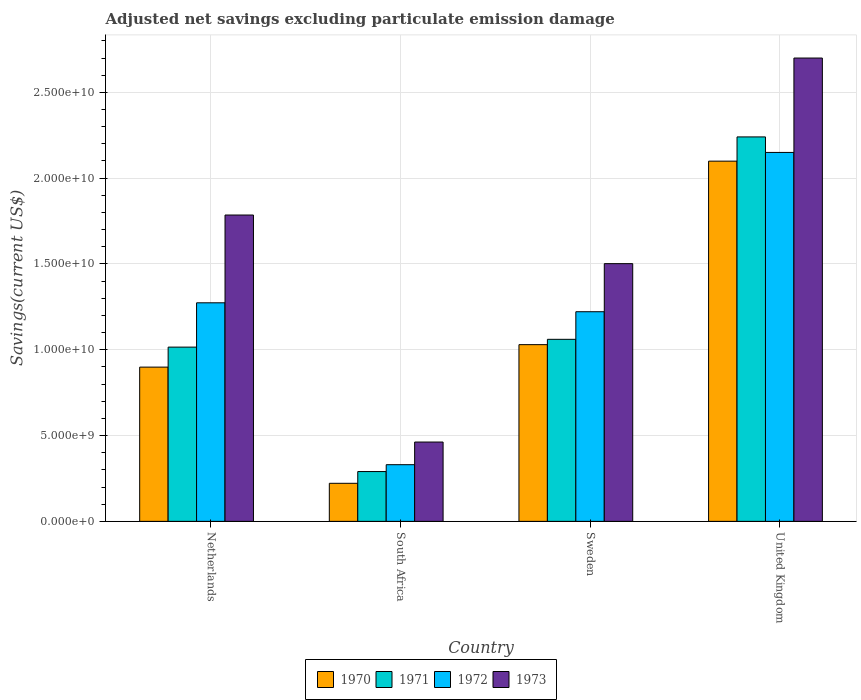Are the number of bars on each tick of the X-axis equal?
Provide a short and direct response. Yes. How many bars are there on the 2nd tick from the left?
Offer a very short reply. 4. What is the label of the 3rd group of bars from the left?
Your answer should be very brief. Sweden. In how many cases, is the number of bars for a given country not equal to the number of legend labels?
Your answer should be very brief. 0. What is the adjusted net savings in 1973 in Sweden?
Your answer should be compact. 1.50e+1. Across all countries, what is the maximum adjusted net savings in 1973?
Your answer should be very brief. 2.70e+1. Across all countries, what is the minimum adjusted net savings in 1970?
Give a very brief answer. 2.22e+09. In which country was the adjusted net savings in 1972 maximum?
Your answer should be compact. United Kingdom. In which country was the adjusted net savings in 1970 minimum?
Offer a terse response. South Africa. What is the total adjusted net savings in 1973 in the graph?
Offer a terse response. 6.45e+1. What is the difference between the adjusted net savings in 1973 in Sweden and that in United Kingdom?
Your answer should be compact. -1.20e+1. What is the difference between the adjusted net savings in 1970 in Netherlands and the adjusted net savings in 1971 in United Kingdom?
Your answer should be very brief. -1.34e+1. What is the average adjusted net savings in 1971 per country?
Your answer should be compact. 1.15e+1. What is the difference between the adjusted net savings of/in 1970 and adjusted net savings of/in 1973 in Netherlands?
Offer a very short reply. -8.86e+09. What is the ratio of the adjusted net savings in 1972 in Netherlands to that in South Africa?
Provide a succinct answer. 3.86. Is the adjusted net savings in 1973 in Sweden less than that in United Kingdom?
Provide a succinct answer. Yes. What is the difference between the highest and the second highest adjusted net savings in 1970?
Your answer should be compact. -1.07e+1. What is the difference between the highest and the lowest adjusted net savings in 1970?
Keep it short and to the point. 1.88e+1. In how many countries, is the adjusted net savings in 1973 greater than the average adjusted net savings in 1973 taken over all countries?
Give a very brief answer. 2. What does the 1st bar from the left in Netherlands represents?
Offer a terse response. 1970. How many bars are there?
Offer a very short reply. 16. Are all the bars in the graph horizontal?
Keep it short and to the point. No. What is the title of the graph?
Offer a terse response. Adjusted net savings excluding particulate emission damage. What is the label or title of the X-axis?
Provide a succinct answer. Country. What is the label or title of the Y-axis?
Your response must be concise. Savings(current US$). What is the Savings(current US$) of 1970 in Netherlands?
Offer a terse response. 8.99e+09. What is the Savings(current US$) in 1971 in Netherlands?
Ensure brevity in your answer.  1.02e+1. What is the Savings(current US$) in 1972 in Netherlands?
Keep it short and to the point. 1.27e+1. What is the Savings(current US$) of 1973 in Netherlands?
Your answer should be compact. 1.79e+1. What is the Savings(current US$) in 1970 in South Africa?
Keep it short and to the point. 2.22e+09. What is the Savings(current US$) in 1971 in South Africa?
Provide a succinct answer. 2.90e+09. What is the Savings(current US$) of 1972 in South Africa?
Your response must be concise. 3.30e+09. What is the Savings(current US$) of 1973 in South Africa?
Your response must be concise. 4.62e+09. What is the Savings(current US$) of 1970 in Sweden?
Give a very brief answer. 1.03e+1. What is the Savings(current US$) of 1971 in Sweden?
Your answer should be compact. 1.06e+1. What is the Savings(current US$) of 1972 in Sweden?
Offer a terse response. 1.22e+1. What is the Savings(current US$) of 1973 in Sweden?
Provide a succinct answer. 1.50e+1. What is the Savings(current US$) of 1970 in United Kingdom?
Ensure brevity in your answer.  2.10e+1. What is the Savings(current US$) of 1971 in United Kingdom?
Ensure brevity in your answer.  2.24e+1. What is the Savings(current US$) in 1972 in United Kingdom?
Ensure brevity in your answer.  2.15e+1. What is the Savings(current US$) of 1973 in United Kingdom?
Provide a succinct answer. 2.70e+1. Across all countries, what is the maximum Savings(current US$) in 1970?
Keep it short and to the point. 2.10e+1. Across all countries, what is the maximum Savings(current US$) in 1971?
Your answer should be compact. 2.24e+1. Across all countries, what is the maximum Savings(current US$) of 1972?
Keep it short and to the point. 2.15e+1. Across all countries, what is the maximum Savings(current US$) of 1973?
Provide a succinct answer. 2.70e+1. Across all countries, what is the minimum Savings(current US$) of 1970?
Your answer should be very brief. 2.22e+09. Across all countries, what is the minimum Savings(current US$) in 1971?
Your response must be concise. 2.90e+09. Across all countries, what is the minimum Savings(current US$) of 1972?
Keep it short and to the point. 3.30e+09. Across all countries, what is the minimum Savings(current US$) in 1973?
Offer a terse response. 4.62e+09. What is the total Savings(current US$) in 1970 in the graph?
Provide a succinct answer. 4.25e+1. What is the total Savings(current US$) in 1971 in the graph?
Your answer should be compact. 4.61e+1. What is the total Savings(current US$) in 1972 in the graph?
Ensure brevity in your answer.  4.98e+1. What is the total Savings(current US$) in 1973 in the graph?
Ensure brevity in your answer.  6.45e+1. What is the difference between the Savings(current US$) of 1970 in Netherlands and that in South Africa?
Offer a terse response. 6.77e+09. What is the difference between the Savings(current US$) in 1971 in Netherlands and that in South Africa?
Make the answer very short. 7.25e+09. What is the difference between the Savings(current US$) in 1972 in Netherlands and that in South Africa?
Your answer should be compact. 9.43e+09. What is the difference between the Savings(current US$) of 1973 in Netherlands and that in South Africa?
Your answer should be compact. 1.32e+1. What is the difference between the Savings(current US$) of 1970 in Netherlands and that in Sweden?
Provide a succinct answer. -1.31e+09. What is the difference between the Savings(current US$) in 1971 in Netherlands and that in Sweden?
Provide a succinct answer. -4.54e+08. What is the difference between the Savings(current US$) of 1972 in Netherlands and that in Sweden?
Give a very brief answer. 5.20e+08. What is the difference between the Savings(current US$) in 1973 in Netherlands and that in Sweden?
Your answer should be very brief. 2.83e+09. What is the difference between the Savings(current US$) in 1970 in Netherlands and that in United Kingdom?
Offer a terse response. -1.20e+1. What is the difference between the Savings(current US$) in 1971 in Netherlands and that in United Kingdom?
Make the answer very short. -1.22e+1. What is the difference between the Savings(current US$) in 1972 in Netherlands and that in United Kingdom?
Your answer should be very brief. -8.76e+09. What is the difference between the Savings(current US$) in 1973 in Netherlands and that in United Kingdom?
Give a very brief answer. -9.15e+09. What is the difference between the Savings(current US$) in 1970 in South Africa and that in Sweden?
Your answer should be compact. -8.08e+09. What is the difference between the Savings(current US$) of 1971 in South Africa and that in Sweden?
Ensure brevity in your answer.  -7.70e+09. What is the difference between the Savings(current US$) of 1972 in South Africa and that in Sweden?
Provide a short and direct response. -8.91e+09. What is the difference between the Savings(current US$) in 1973 in South Africa and that in Sweden?
Your response must be concise. -1.04e+1. What is the difference between the Savings(current US$) of 1970 in South Africa and that in United Kingdom?
Your response must be concise. -1.88e+1. What is the difference between the Savings(current US$) in 1971 in South Africa and that in United Kingdom?
Give a very brief answer. -1.95e+1. What is the difference between the Savings(current US$) in 1972 in South Africa and that in United Kingdom?
Provide a succinct answer. -1.82e+1. What is the difference between the Savings(current US$) of 1973 in South Africa and that in United Kingdom?
Provide a succinct answer. -2.24e+1. What is the difference between the Savings(current US$) of 1970 in Sweden and that in United Kingdom?
Offer a very short reply. -1.07e+1. What is the difference between the Savings(current US$) in 1971 in Sweden and that in United Kingdom?
Offer a very short reply. -1.18e+1. What is the difference between the Savings(current US$) in 1972 in Sweden and that in United Kingdom?
Give a very brief answer. -9.28e+09. What is the difference between the Savings(current US$) of 1973 in Sweden and that in United Kingdom?
Keep it short and to the point. -1.20e+1. What is the difference between the Savings(current US$) of 1970 in Netherlands and the Savings(current US$) of 1971 in South Africa?
Ensure brevity in your answer.  6.09e+09. What is the difference between the Savings(current US$) of 1970 in Netherlands and the Savings(current US$) of 1972 in South Africa?
Ensure brevity in your answer.  5.69e+09. What is the difference between the Savings(current US$) in 1970 in Netherlands and the Savings(current US$) in 1973 in South Africa?
Offer a terse response. 4.37e+09. What is the difference between the Savings(current US$) in 1971 in Netherlands and the Savings(current US$) in 1972 in South Africa?
Give a very brief answer. 6.85e+09. What is the difference between the Savings(current US$) of 1971 in Netherlands and the Savings(current US$) of 1973 in South Africa?
Offer a terse response. 5.53e+09. What is the difference between the Savings(current US$) in 1972 in Netherlands and the Savings(current US$) in 1973 in South Africa?
Your answer should be very brief. 8.11e+09. What is the difference between the Savings(current US$) in 1970 in Netherlands and the Savings(current US$) in 1971 in Sweden?
Offer a terse response. -1.62e+09. What is the difference between the Savings(current US$) of 1970 in Netherlands and the Savings(current US$) of 1972 in Sweden?
Make the answer very short. -3.23e+09. What is the difference between the Savings(current US$) in 1970 in Netherlands and the Savings(current US$) in 1973 in Sweden?
Offer a very short reply. -6.03e+09. What is the difference between the Savings(current US$) in 1971 in Netherlands and the Savings(current US$) in 1972 in Sweden?
Offer a very short reply. -2.06e+09. What is the difference between the Savings(current US$) in 1971 in Netherlands and the Savings(current US$) in 1973 in Sweden?
Keep it short and to the point. -4.86e+09. What is the difference between the Savings(current US$) of 1972 in Netherlands and the Savings(current US$) of 1973 in Sweden?
Offer a very short reply. -2.28e+09. What is the difference between the Savings(current US$) in 1970 in Netherlands and the Savings(current US$) in 1971 in United Kingdom?
Your answer should be compact. -1.34e+1. What is the difference between the Savings(current US$) of 1970 in Netherlands and the Savings(current US$) of 1972 in United Kingdom?
Your response must be concise. -1.25e+1. What is the difference between the Savings(current US$) in 1970 in Netherlands and the Savings(current US$) in 1973 in United Kingdom?
Your answer should be compact. -1.80e+1. What is the difference between the Savings(current US$) in 1971 in Netherlands and the Savings(current US$) in 1972 in United Kingdom?
Make the answer very short. -1.13e+1. What is the difference between the Savings(current US$) in 1971 in Netherlands and the Savings(current US$) in 1973 in United Kingdom?
Provide a succinct answer. -1.68e+1. What is the difference between the Savings(current US$) in 1972 in Netherlands and the Savings(current US$) in 1973 in United Kingdom?
Make the answer very short. -1.43e+1. What is the difference between the Savings(current US$) in 1970 in South Africa and the Savings(current US$) in 1971 in Sweden?
Provide a succinct answer. -8.39e+09. What is the difference between the Savings(current US$) in 1970 in South Africa and the Savings(current US$) in 1972 in Sweden?
Your answer should be very brief. -1.00e+1. What is the difference between the Savings(current US$) in 1970 in South Africa and the Savings(current US$) in 1973 in Sweden?
Offer a terse response. -1.28e+1. What is the difference between the Savings(current US$) of 1971 in South Africa and the Savings(current US$) of 1972 in Sweden?
Give a very brief answer. -9.31e+09. What is the difference between the Savings(current US$) of 1971 in South Africa and the Savings(current US$) of 1973 in Sweden?
Your response must be concise. -1.21e+1. What is the difference between the Savings(current US$) in 1972 in South Africa and the Savings(current US$) in 1973 in Sweden?
Make the answer very short. -1.17e+1. What is the difference between the Savings(current US$) of 1970 in South Africa and the Savings(current US$) of 1971 in United Kingdom?
Offer a terse response. -2.02e+1. What is the difference between the Savings(current US$) in 1970 in South Africa and the Savings(current US$) in 1972 in United Kingdom?
Give a very brief answer. -1.93e+1. What is the difference between the Savings(current US$) of 1970 in South Africa and the Savings(current US$) of 1973 in United Kingdom?
Provide a succinct answer. -2.48e+1. What is the difference between the Savings(current US$) of 1971 in South Africa and the Savings(current US$) of 1972 in United Kingdom?
Your answer should be compact. -1.86e+1. What is the difference between the Savings(current US$) in 1971 in South Africa and the Savings(current US$) in 1973 in United Kingdom?
Keep it short and to the point. -2.41e+1. What is the difference between the Savings(current US$) of 1972 in South Africa and the Savings(current US$) of 1973 in United Kingdom?
Offer a terse response. -2.37e+1. What is the difference between the Savings(current US$) in 1970 in Sweden and the Savings(current US$) in 1971 in United Kingdom?
Make the answer very short. -1.21e+1. What is the difference between the Savings(current US$) in 1970 in Sweden and the Savings(current US$) in 1972 in United Kingdom?
Ensure brevity in your answer.  -1.12e+1. What is the difference between the Savings(current US$) in 1970 in Sweden and the Savings(current US$) in 1973 in United Kingdom?
Offer a very short reply. -1.67e+1. What is the difference between the Savings(current US$) in 1971 in Sweden and the Savings(current US$) in 1972 in United Kingdom?
Make the answer very short. -1.09e+1. What is the difference between the Savings(current US$) of 1971 in Sweden and the Savings(current US$) of 1973 in United Kingdom?
Your response must be concise. -1.64e+1. What is the difference between the Savings(current US$) of 1972 in Sweden and the Savings(current US$) of 1973 in United Kingdom?
Your response must be concise. -1.48e+1. What is the average Savings(current US$) of 1970 per country?
Keep it short and to the point. 1.06e+1. What is the average Savings(current US$) in 1971 per country?
Keep it short and to the point. 1.15e+1. What is the average Savings(current US$) in 1972 per country?
Ensure brevity in your answer.  1.24e+1. What is the average Savings(current US$) in 1973 per country?
Your answer should be compact. 1.61e+1. What is the difference between the Savings(current US$) of 1970 and Savings(current US$) of 1971 in Netherlands?
Offer a very short reply. -1.17e+09. What is the difference between the Savings(current US$) in 1970 and Savings(current US$) in 1972 in Netherlands?
Your answer should be very brief. -3.75e+09. What is the difference between the Savings(current US$) of 1970 and Savings(current US$) of 1973 in Netherlands?
Offer a very short reply. -8.86e+09. What is the difference between the Savings(current US$) of 1971 and Savings(current US$) of 1972 in Netherlands?
Your response must be concise. -2.58e+09. What is the difference between the Savings(current US$) of 1971 and Savings(current US$) of 1973 in Netherlands?
Provide a short and direct response. -7.70e+09. What is the difference between the Savings(current US$) of 1972 and Savings(current US$) of 1973 in Netherlands?
Your answer should be compact. -5.11e+09. What is the difference between the Savings(current US$) of 1970 and Savings(current US$) of 1971 in South Africa?
Provide a short and direct response. -6.85e+08. What is the difference between the Savings(current US$) in 1970 and Savings(current US$) in 1972 in South Africa?
Make the answer very short. -1.08e+09. What is the difference between the Savings(current US$) of 1970 and Savings(current US$) of 1973 in South Africa?
Make the answer very short. -2.40e+09. What is the difference between the Savings(current US$) of 1971 and Savings(current US$) of 1972 in South Africa?
Ensure brevity in your answer.  -4.00e+08. What is the difference between the Savings(current US$) in 1971 and Savings(current US$) in 1973 in South Africa?
Offer a terse response. -1.72e+09. What is the difference between the Savings(current US$) of 1972 and Savings(current US$) of 1973 in South Africa?
Offer a terse response. -1.32e+09. What is the difference between the Savings(current US$) of 1970 and Savings(current US$) of 1971 in Sweden?
Ensure brevity in your answer.  -3.10e+08. What is the difference between the Savings(current US$) of 1970 and Savings(current US$) of 1972 in Sweden?
Make the answer very short. -1.92e+09. What is the difference between the Savings(current US$) of 1970 and Savings(current US$) of 1973 in Sweden?
Ensure brevity in your answer.  -4.72e+09. What is the difference between the Savings(current US$) of 1971 and Savings(current US$) of 1972 in Sweden?
Provide a succinct answer. -1.61e+09. What is the difference between the Savings(current US$) in 1971 and Savings(current US$) in 1973 in Sweden?
Provide a succinct answer. -4.41e+09. What is the difference between the Savings(current US$) of 1972 and Savings(current US$) of 1973 in Sweden?
Offer a terse response. -2.80e+09. What is the difference between the Savings(current US$) in 1970 and Savings(current US$) in 1971 in United Kingdom?
Ensure brevity in your answer.  -1.41e+09. What is the difference between the Savings(current US$) in 1970 and Savings(current US$) in 1972 in United Kingdom?
Offer a very short reply. -5.08e+08. What is the difference between the Savings(current US$) in 1970 and Savings(current US$) in 1973 in United Kingdom?
Give a very brief answer. -6.01e+09. What is the difference between the Savings(current US$) of 1971 and Savings(current US$) of 1972 in United Kingdom?
Keep it short and to the point. 9.03e+08. What is the difference between the Savings(current US$) in 1971 and Savings(current US$) in 1973 in United Kingdom?
Ensure brevity in your answer.  -4.60e+09. What is the difference between the Savings(current US$) in 1972 and Savings(current US$) in 1973 in United Kingdom?
Keep it short and to the point. -5.50e+09. What is the ratio of the Savings(current US$) of 1970 in Netherlands to that in South Africa?
Your answer should be compact. 4.05. What is the ratio of the Savings(current US$) in 1971 in Netherlands to that in South Africa?
Provide a succinct answer. 3.5. What is the ratio of the Savings(current US$) in 1972 in Netherlands to that in South Africa?
Offer a very short reply. 3.86. What is the ratio of the Savings(current US$) in 1973 in Netherlands to that in South Africa?
Keep it short and to the point. 3.86. What is the ratio of the Savings(current US$) in 1970 in Netherlands to that in Sweden?
Offer a terse response. 0.87. What is the ratio of the Savings(current US$) in 1971 in Netherlands to that in Sweden?
Provide a succinct answer. 0.96. What is the ratio of the Savings(current US$) of 1972 in Netherlands to that in Sweden?
Give a very brief answer. 1.04. What is the ratio of the Savings(current US$) in 1973 in Netherlands to that in Sweden?
Your answer should be very brief. 1.19. What is the ratio of the Savings(current US$) in 1970 in Netherlands to that in United Kingdom?
Offer a very short reply. 0.43. What is the ratio of the Savings(current US$) of 1971 in Netherlands to that in United Kingdom?
Give a very brief answer. 0.45. What is the ratio of the Savings(current US$) in 1972 in Netherlands to that in United Kingdom?
Provide a succinct answer. 0.59. What is the ratio of the Savings(current US$) of 1973 in Netherlands to that in United Kingdom?
Ensure brevity in your answer.  0.66. What is the ratio of the Savings(current US$) in 1970 in South Africa to that in Sweden?
Offer a very short reply. 0.22. What is the ratio of the Savings(current US$) of 1971 in South Africa to that in Sweden?
Provide a short and direct response. 0.27. What is the ratio of the Savings(current US$) of 1972 in South Africa to that in Sweden?
Keep it short and to the point. 0.27. What is the ratio of the Savings(current US$) in 1973 in South Africa to that in Sweden?
Provide a succinct answer. 0.31. What is the ratio of the Savings(current US$) of 1970 in South Africa to that in United Kingdom?
Provide a succinct answer. 0.11. What is the ratio of the Savings(current US$) in 1971 in South Africa to that in United Kingdom?
Your answer should be very brief. 0.13. What is the ratio of the Savings(current US$) of 1972 in South Africa to that in United Kingdom?
Offer a terse response. 0.15. What is the ratio of the Savings(current US$) in 1973 in South Africa to that in United Kingdom?
Your answer should be compact. 0.17. What is the ratio of the Savings(current US$) of 1970 in Sweden to that in United Kingdom?
Provide a succinct answer. 0.49. What is the ratio of the Savings(current US$) of 1971 in Sweden to that in United Kingdom?
Provide a short and direct response. 0.47. What is the ratio of the Savings(current US$) in 1972 in Sweden to that in United Kingdom?
Provide a succinct answer. 0.57. What is the ratio of the Savings(current US$) in 1973 in Sweden to that in United Kingdom?
Your response must be concise. 0.56. What is the difference between the highest and the second highest Savings(current US$) of 1970?
Provide a short and direct response. 1.07e+1. What is the difference between the highest and the second highest Savings(current US$) in 1971?
Keep it short and to the point. 1.18e+1. What is the difference between the highest and the second highest Savings(current US$) in 1972?
Give a very brief answer. 8.76e+09. What is the difference between the highest and the second highest Savings(current US$) of 1973?
Give a very brief answer. 9.15e+09. What is the difference between the highest and the lowest Savings(current US$) of 1970?
Offer a very short reply. 1.88e+1. What is the difference between the highest and the lowest Savings(current US$) of 1971?
Provide a succinct answer. 1.95e+1. What is the difference between the highest and the lowest Savings(current US$) in 1972?
Offer a very short reply. 1.82e+1. What is the difference between the highest and the lowest Savings(current US$) in 1973?
Ensure brevity in your answer.  2.24e+1. 